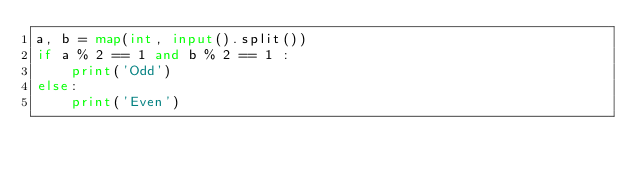<code> <loc_0><loc_0><loc_500><loc_500><_Python_>a, b = map(int, input().split())
if a % 2 == 1 and b % 2 == 1 :
    print('Odd')
else:
    print('Even')</code> 